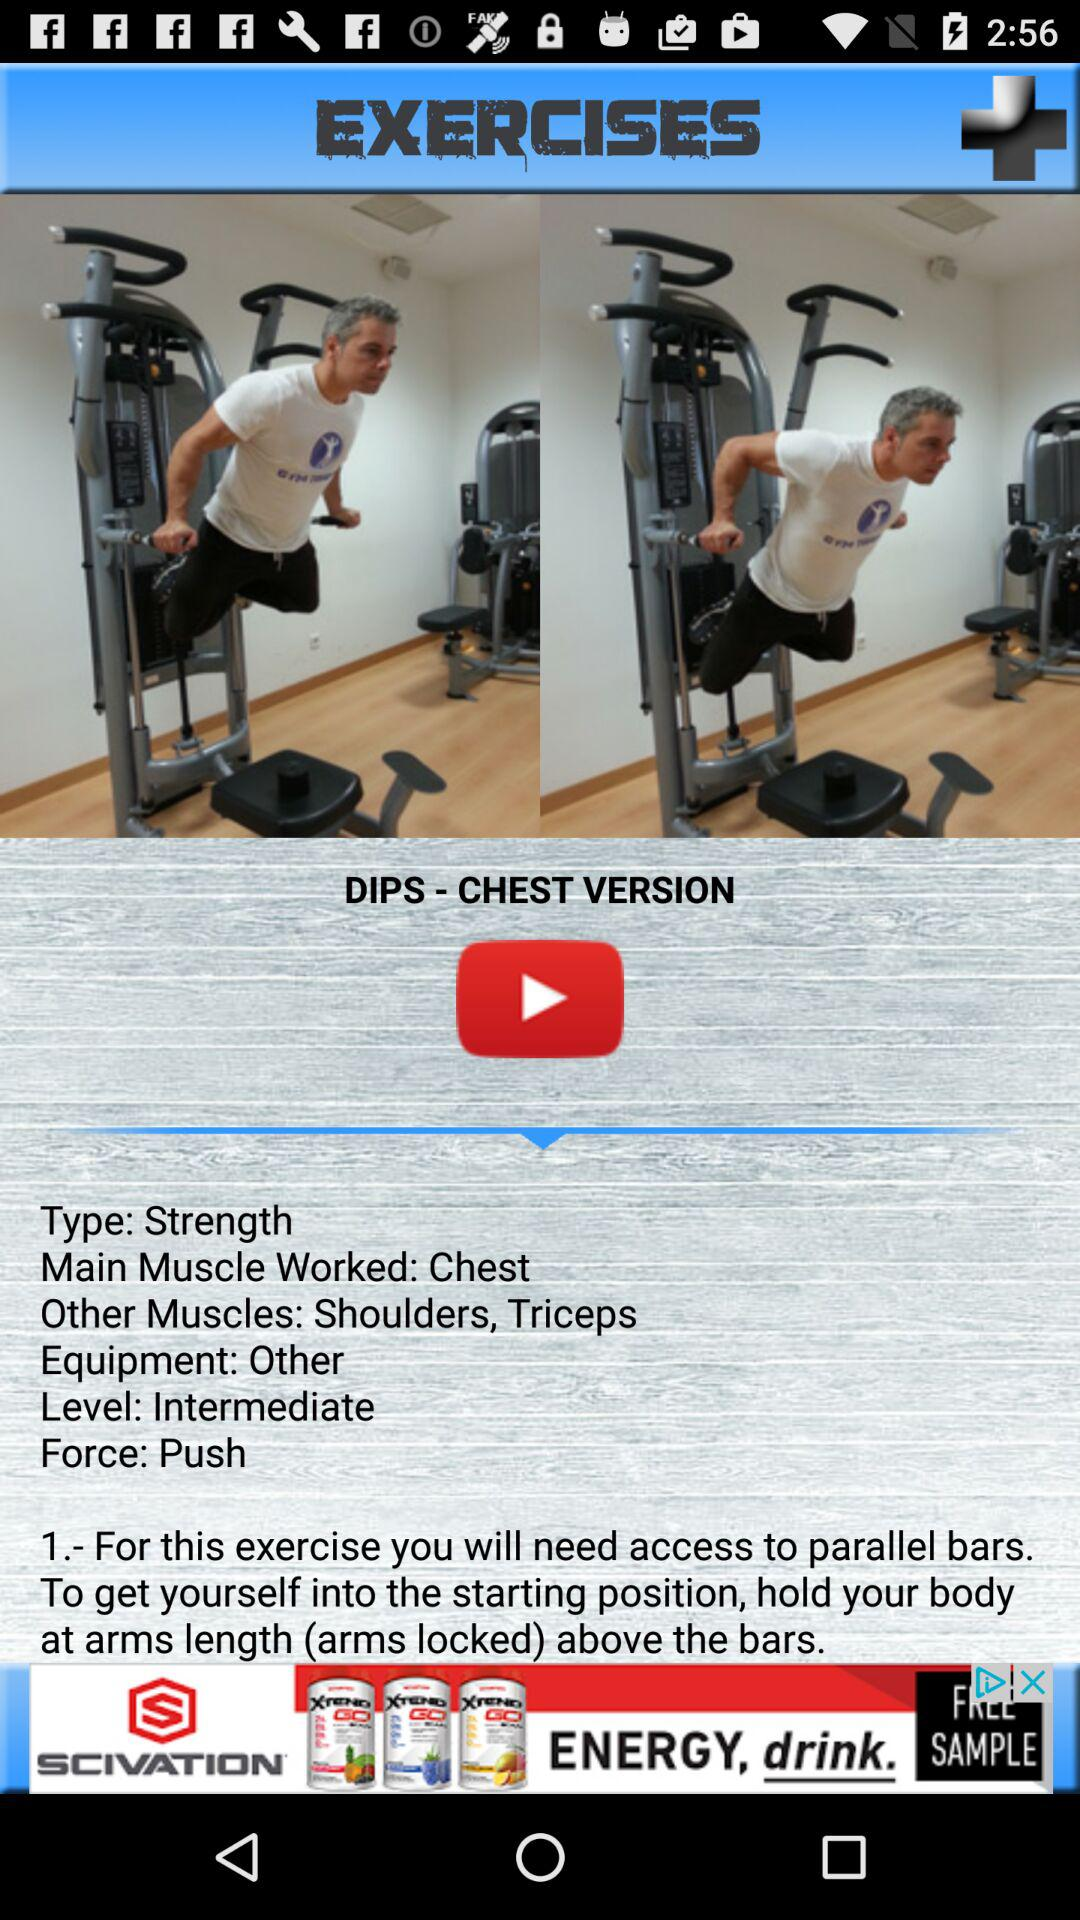What's the exercise name? The exercise name is Dips-Chest Version. 